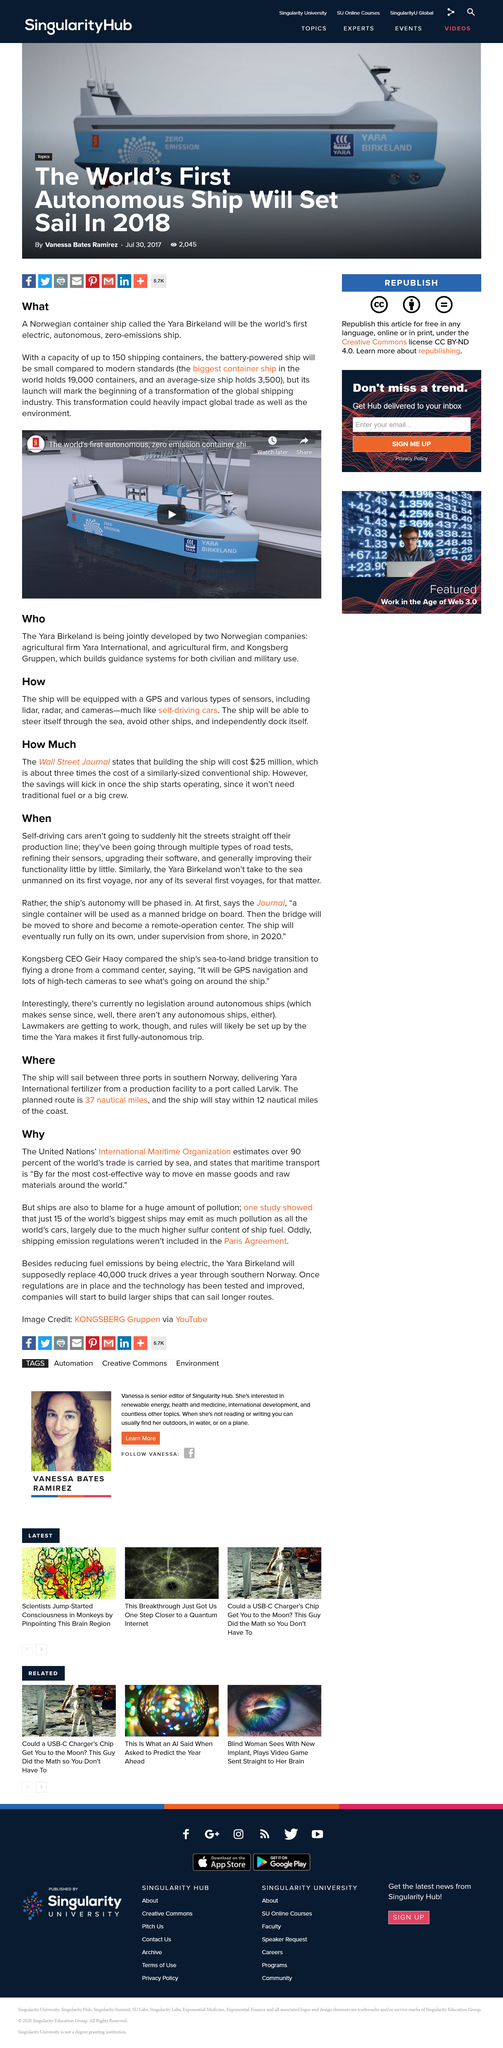Give some essential details in this illustration. The planned route is expected to be 37 nautical miles in length. The ship will deliver Yara International fertilizer, produced at a facility, to the port of Larvik. The ship is capable of holding up to 150 shipping containers. According to the United Nations' International Maritime Organization, over 90 percent of the world's trade is carried by sea. The ship will be outfitted with state-of-the-art GPS technology and an array of specialized sensors, including lidar, radar, and cameras, to enhance its navigational and surveillance capabilities. 